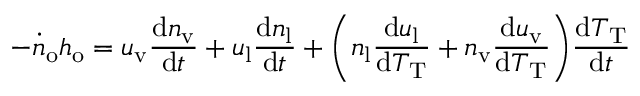<formula> <loc_0><loc_0><loc_500><loc_500>- \dot { n } _ { o } h _ { o } = u _ { v } \frac { d n _ { v } } { d t } + u _ { l } \frac { d n _ { l } } { d t } + \left ( n _ { l } \frac { d u _ { l } } { d T _ { T } } + n _ { v } \frac { d u _ { v } } { d T _ { T } } \right ) \frac { d T _ { T } } { d t }</formula> 